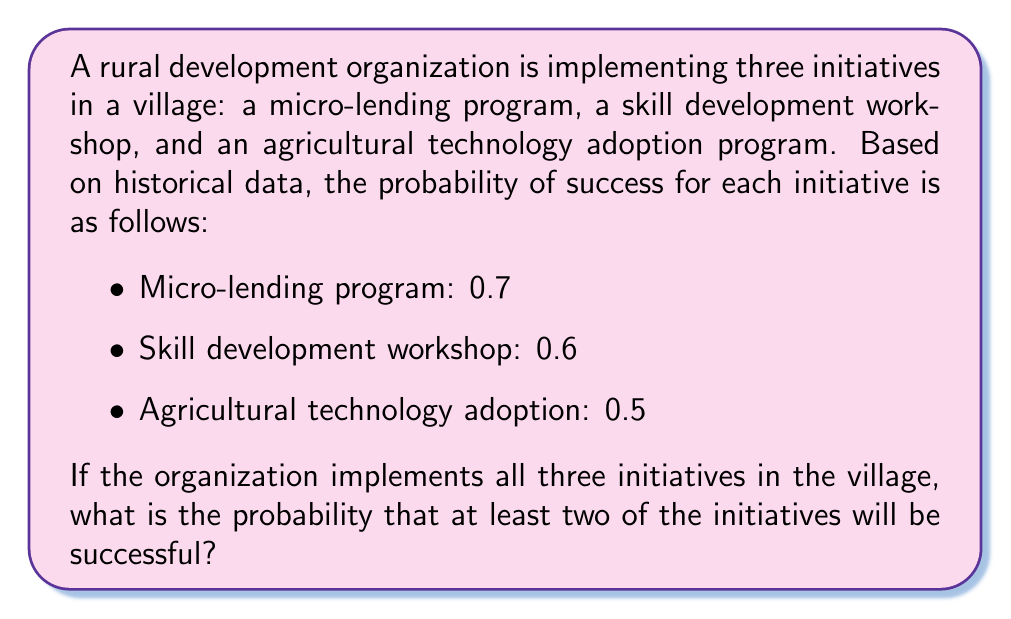Give your solution to this math problem. To solve this problem, we'll use probability theory, specifically the concept of complementary events and the addition rule of probability.

Let's approach this step-by-step:

1) First, let's define our events:
   A: Micro-lending program is successful (P(A) = 0.7)
   B: Skill development workshop is successful (P(B) = 0.6)
   C: Agricultural technology adoption is successful (P(C) = 0.5)

2) We want to find the probability of at least two initiatives being successful. It's easier to calculate the complement of this event: the probability of zero or one initiative being successful.

3) Let's calculate the probabilities of these complementary events:
   
   P(no success) = P(A' ∩ B' ∩ C') = (1-0.7) × (1-0.6) × (1-0.5) = 0.3 × 0.4 × 0.5 = 0.06

   P(exactly one success) = P(A ∩ B' ∩ C') + P(A' ∩ B ∩ C') + P(A' ∩ B' ∩ C)
                          = 0.7 × 0.4 × 0.5 + 0.3 × 0.6 × 0.5 + 0.3 × 0.4 × 0.5
                          = 0.14 + 0.09 + 0.06 = 0.29

4) Now, the probability of zero or one success is:
   P(zero or one success) = 0.06 + 0.29 = 0.35

5) Therefore, the probability of at least two successes is the complement of this:
   P(at least two successes) = 1 - P(zero or one success) = 1 - 0.35 = 0.65

Thus, the probability that at least two of the initiatives will be successful is 0.65 or 65%.
Answer: The probability that at least two of the three rural development initiatives will be successful is 0.65 or 65%. 